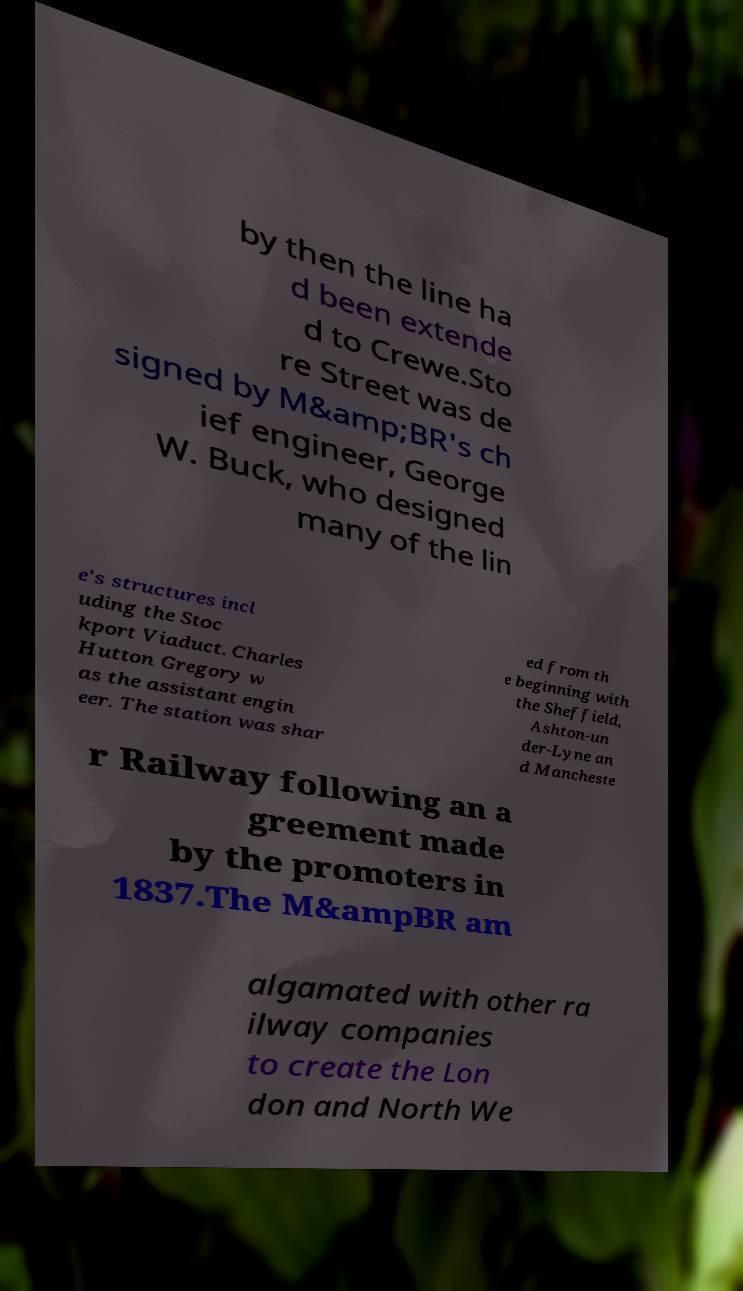Could you assist in decoding the text presented in this image and type it out clearly? by then the line ha d been extende d to Crewe.Sto re Street was de signed by M&amp;BR's ch ief engineer, George W. Buck, who designed many of the lin e's structures incl uding the Stoc kport Viaduct. Charles Hutton Gregory w as the assistant engin eer. The station was shar ed from th e beginning with the Sheffield, Ashton-un der-Lyne an d Mancheste r Railway following an a greement made by the promoters in 1837.The M&ampBR am algamated with other ra ilway companies to create the Lon don and North We 